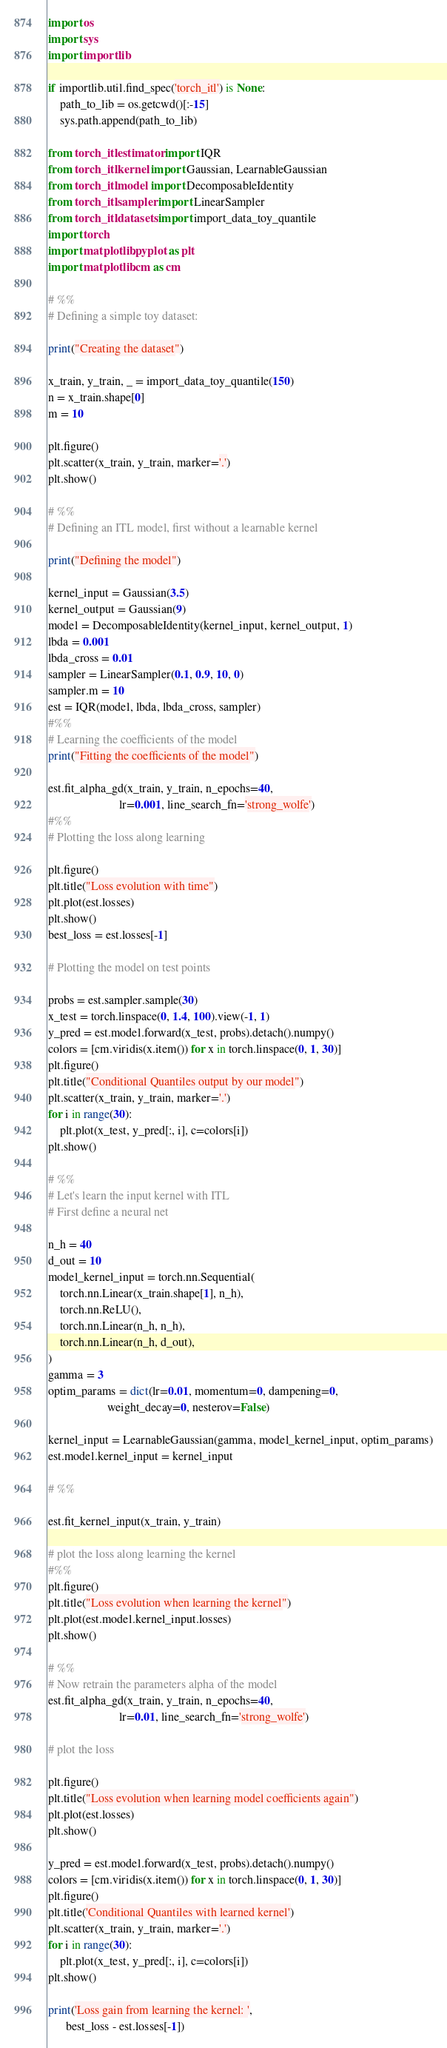Convert code to text. <code><loc_0><loc_0><loc_500><loc_500><_Python_>import os
import sys
import importlib

if importlib.util.find_spec('torch_itl') is None:
    path_to_lib = os.getcwd()[:-15]
    sys.path.append(path_to_lib)

from torch_itl.estimator import IQR
from torch_itl.kernel import Gaussian, LearnableGaussian
from torch_itl.model import DecomposableIdentity
from torch_itl.sampler import LinearSampler
from torch_itl.datasets import import_data_toy_quantile
import torch
import matplotlib.pyplot as plt
import matplotlib.cm as cm

# %%
# Defining a simple toy dataset:

print("Creating the dataset")

x_train, y_train, _ = import_data_toy_quantile(150)
n = x_train.shape[0]
m = 10

plt.figure()
plt.scatter(x_train, y_train, marker='.')
plt.show()

# %%
# Defining an ITL model, first without a learnable kernel

print("Defining the model")

kernel_input = Gaussian(3.5)
kernel_output = Gaussian(9)
model = DecomposableIdentity(kernel_input, kernel_output, 1)
lbda = 0.001
lbda_cross = 0.01
sampler = LinearSampler(0.1, 0.9, 10, 0)
sampler.m = 10
est = IQR(model, lbda, lbda_cross, sampler)
#%%
# Learning the coefficients of the model
print("Fitting the coefficients of the model")

est.fit_alpha_gd(x_train, y_train, n_epochs=40,
                        lr=0.001, line_search_fn='strong_wolfe')
#%%
# Plotting the loss along learning

plt.figure()
plt.title("Loss evolution with time")
plt.plot(est.losses)
plt.show()
best_loss = est.losses[-1]

# Plotting the model on test points

probs = est.sampler.sample(30)
x_test = torch.linspace(0, 1.4, 100).view(-1, 1)
y_pred = est.model.forward(x_test, probs).detach().numpy()
colors = [cm.viridis(x.item()) for x in torch.linspace(0, 1, 30)]
plt.figure()
plt.title("Conditional Quantiles output by our model")
plt.scatter(x_train, y_train, marker='.')
for i in range(30):
    plt.plot(x_test, y_pred[:, i], c=colors[i])
plt.show()

# %%
# Let's learn the input kernel with ITL
# First define a neural net

n_h = 40
d_out = 10
model_kernel_input = torch.nn.Sequential(
    torch.nn.Linear(x_train.shape[1], n_h),
    torch.nn.ReLU(),
    torch.nn.Linear(n_h, n_h),
    torch.nn.Linear(n_h, d_out),
)
gamma = 3
optim_params = dict(lr=0.01, momentum=0, dampening=0,
                    weight_decay=0, nesterov=False)

kernel_input = LearnableGaussian(gamma, model_kernel_input, optim_params)
est.model.kernel_input = kernel_input

# %%

est.fit_kernel_input(x_train, y_train)

# plot the loss along learning the kernel
#%%
plt.figure()
plt.title("Loss evolution when learning the kernel")
plt.plot(est.model.kernel_input.losses)
plt.show()

# %%
# Now retrain the parameters alpha of the model
est.fit_alpha_gd(x_train, y_train, n_epochs=40,
                        lr=0.01, line_search_fn='strong_wolfe')

# plot the loss

plt.figure()
plt.title("Loss evolution when learning model coefficients again")
plt.plot(est.losses)
plt.show()

y_pred = est.model.forward(x_test, probs).detach().numpy()
colors = [cm.viridis(x.item()) for x in torch.linspace(0, 1, 30)]
plt.figure()
plt.title('Conditional Quantiles with learned kernel')
plt.scatter(x_train, y_train, marker='.')
for i in range(30):
    plt.plot(x_test, y_pred[:, i], c=colors[i])
plt.show()

print('Loss gain from learning the kernel: ',
      best_loss - est.losses[-1])
</code> 